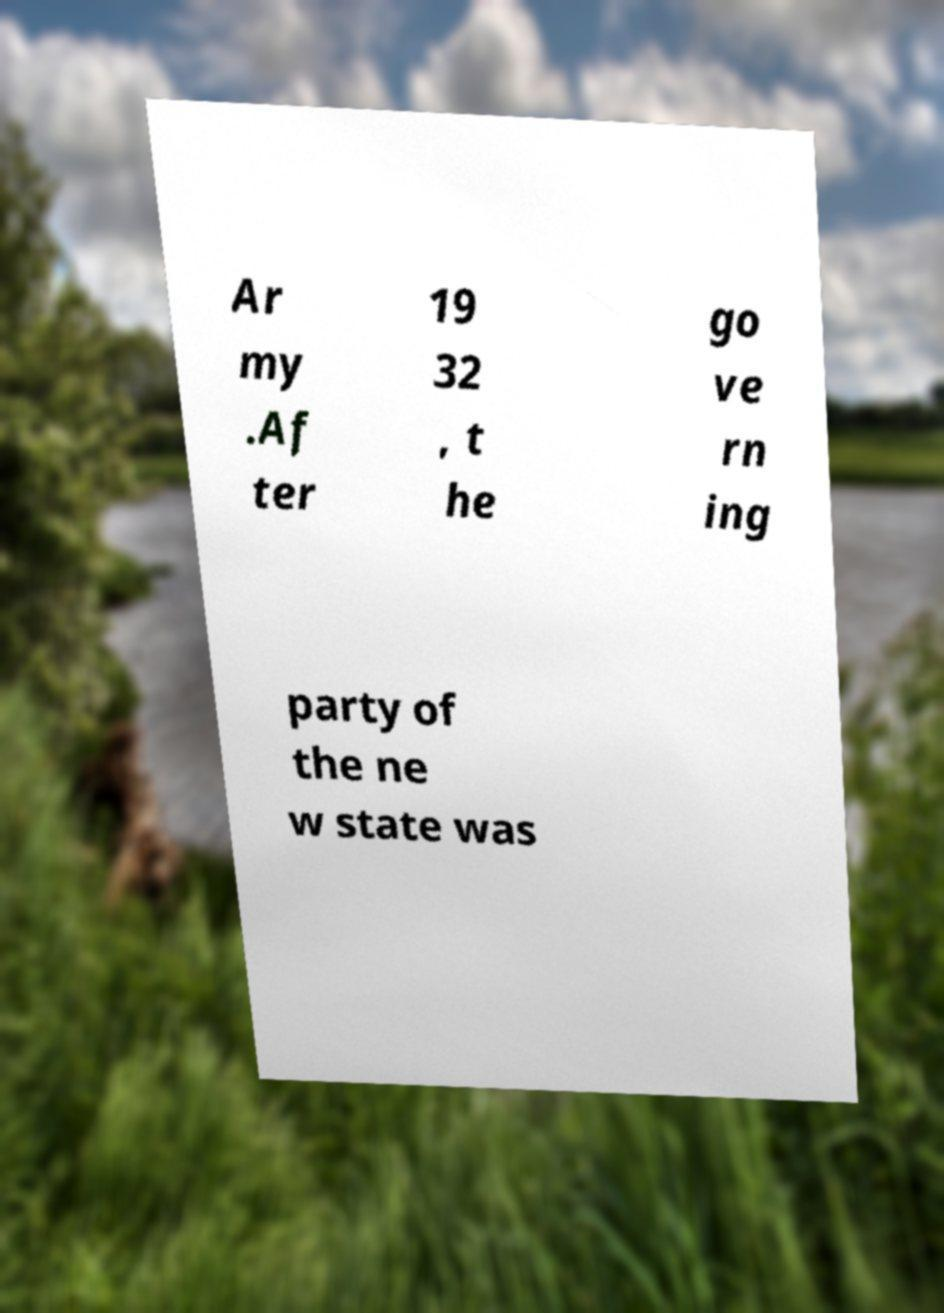Can you accurately transcribe the text from the provided image for me? Ar my .Af ter 19 32 , t he go ve rn ing party of the ne w state was 